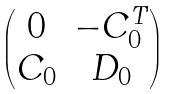Convert formula to latex. <formula><loc_0><loc_0><loc_500><loc_500>\begin{pmatrix} 0 & - C _ { 0 } ^ { T } \\ C _ { 0 } & D _ { 0 } \end{pmatrix}</formula> 